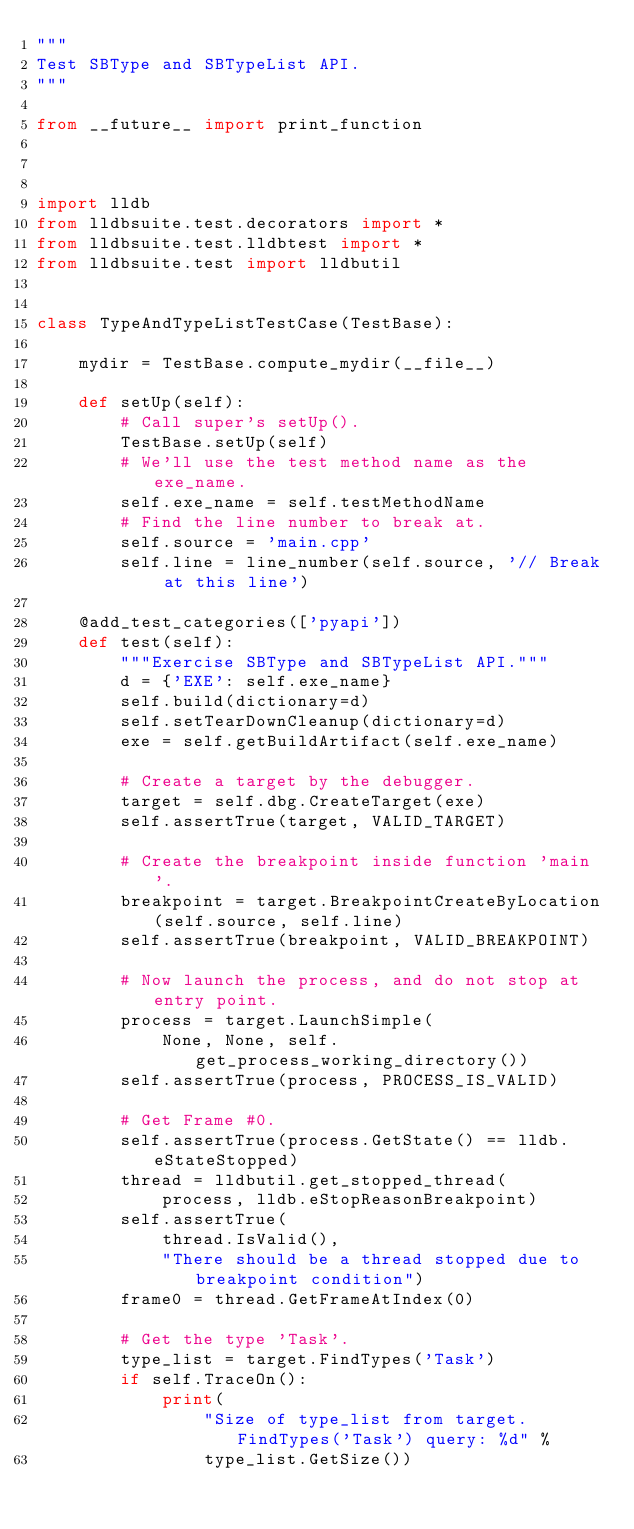<code> <loc_0><loc_0><loc_500><loc_500><_Python_>"""
Test SBType and SBTypeList API.
"""

from __future__ import print_function



import lldb
from lldbsuite.test.decorators import *
from lldbsuite.test.lldbtest import *
from lldbsuite.test import lldbutil


class TypeAndTypeListTestCase(TestBase):

    mydir = TestBase.compute_mydir(__file__)

    def setUp(self):
        # Call super's setUp().
        TestBase.setUp(self)
        # We'll use the test method name as the exe_name.
        self.exe_name = self.testMethodName
        # Find the line number to break at.
        self.source = 'main.cpp'
        self.line = line_number(self.source, '// Break at this line')

    @add_test_categories(['pyapi'])
    def test(self):
        """Exercise SBType and SBTypeList API."""
        d = {'EXE': self.exe_name}
        self.build(dictionary=d)
        self.setTearDownCleanup(dictionary=d)
        exe = self.getBuildArtifact(self.exe_name)

        # Create a target by the debugger.
        target = self.dbg.CreateTarget(exe)
        self.assertTrue(target, VALID_TARGET)

        # Create the breakpoint inside function 'main'.
        breakpoint = target.BreakpointCreateByLocation(self.source, self.line)
        self.assertTrue(breakpoint, VALID_BREAKPOINT)

        # Now launch the process, and do not stop at entry point.
        process = target.LaunchSimple(
            None, None, self.get_process_working_directory())
        self.assertTrue(process, PROCESS_IS_VALID)

        # Get Frame #0.
        self.assertTrue(process.GetState() == lldb.eStateStopped)
        thread = lldbutil.get_stopped_thread(
            process, lldb.eStopReasonBreakpoint)
        self.assertTrue(
            thread.IsValid(),
            "There should be a thread stopped due to breakpoint condition")
        frame0 = thread.GetFrameAtIndex(0)

        # Get the type 'Task'.
        type_list = target.FindTypes('Task')
        if self.TraceOn():
            print(
                "Size of type_list from target.FindTypes('Task') query: %d" %
                type_list.GetSize())</code> 